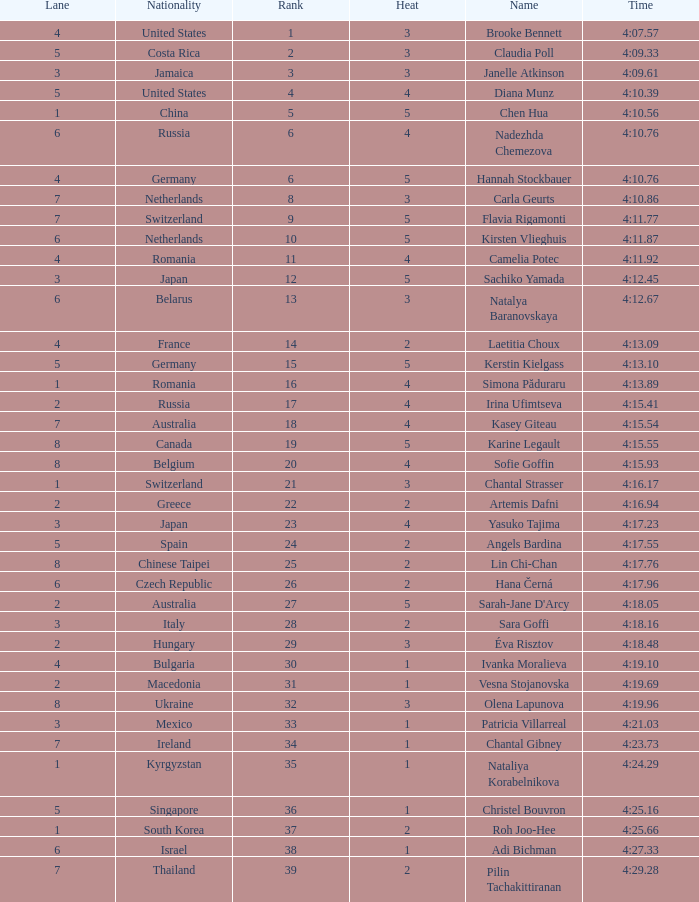Name the least lane for kasey giteau and rank less than 18 None. 